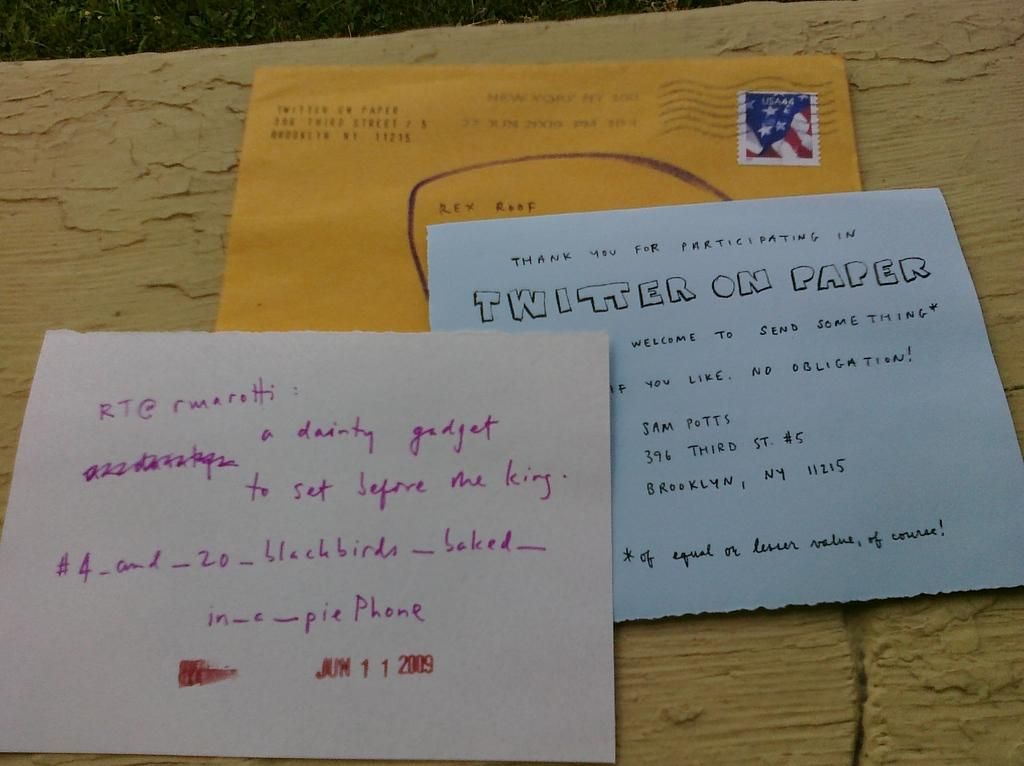Provide a one-sentence caption for the provided image. A Twitter on paper item on a desk. 